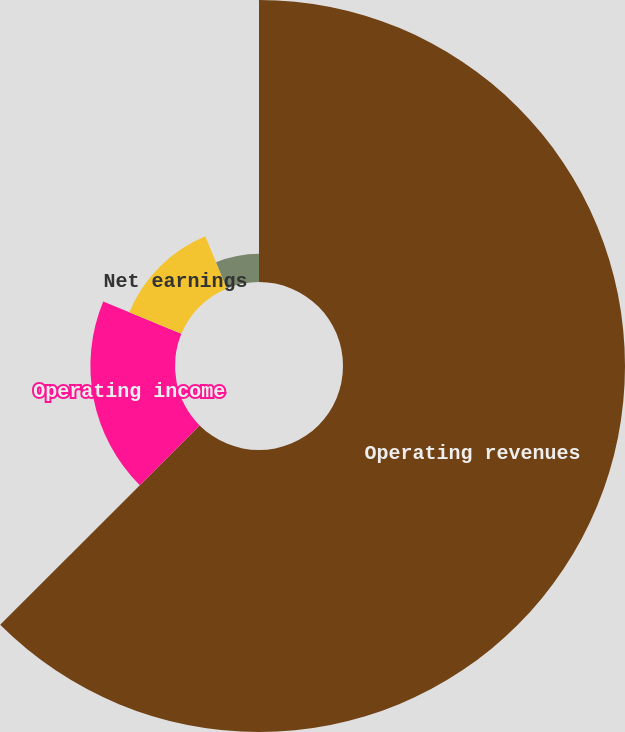<chart> <loc_0><loc_0><loc_500><loc_500><pie_chart><fcel>Operating revenues<fcel>Operating income<fcel>Net earnings<fcel>Basic earnings per share<fcel>Diluted earnings per share<nl><fcel>62.5%<fcel>18.75%<fcel>12.5%<fcel>6.25%<fcel>0.0%<nl></chart> 